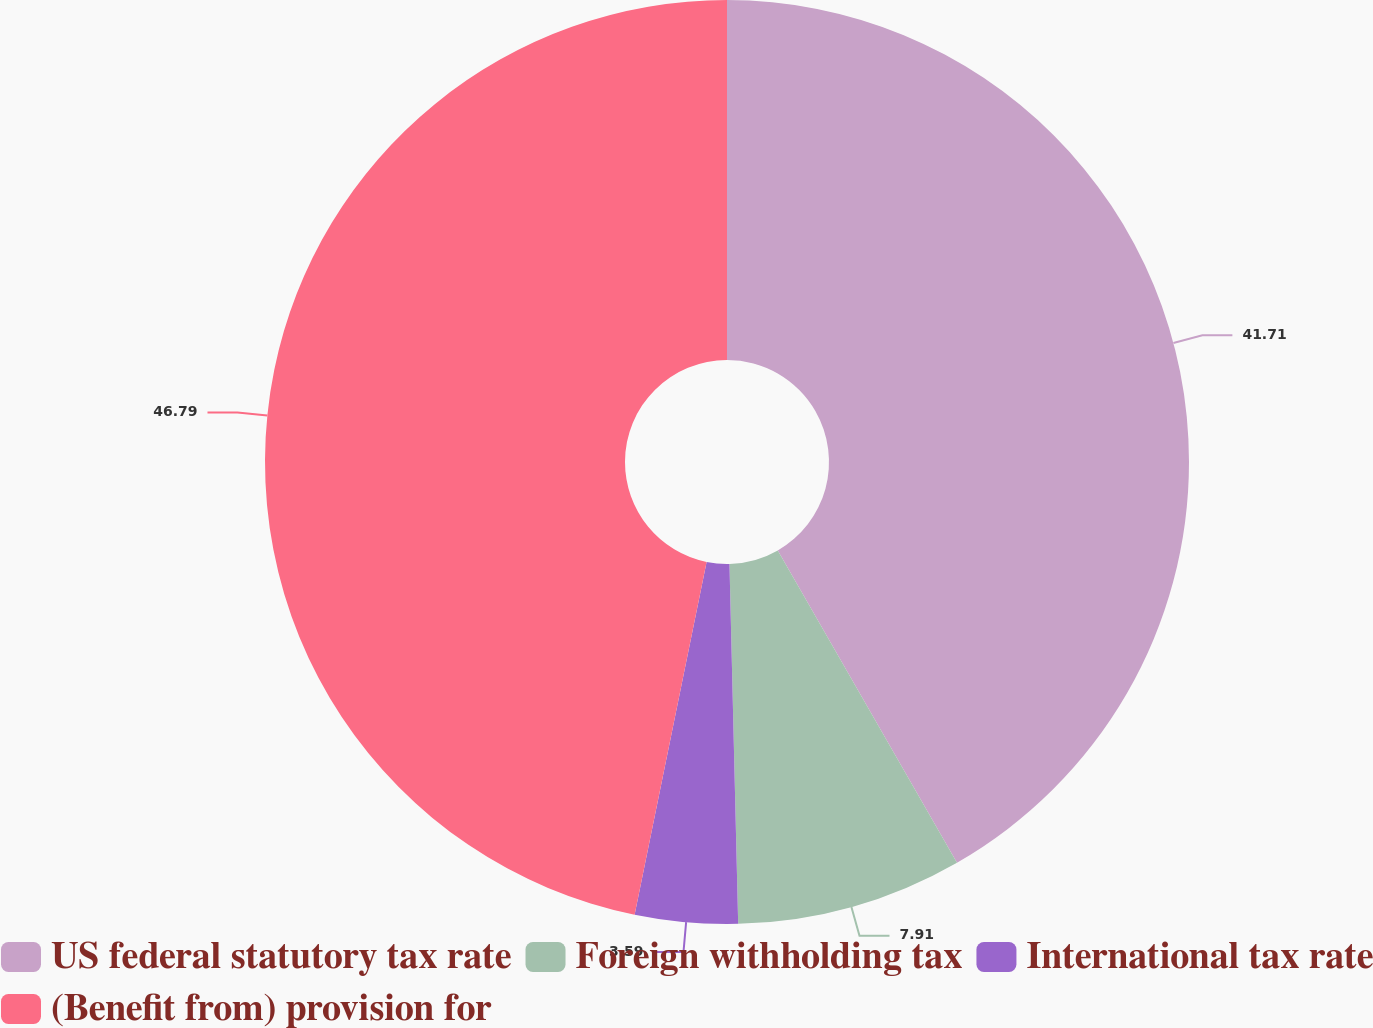Convert chart to OTSL. <chart><loc_0><loc_0><loc_500><loc_500><pie_chart><fcel>US federal statutory tax rate<fcel>Foreign withholding tax<fcel>International tax rate<fcel>(Benefit from) provision for<nl><fcel>41.71%<fcel>7.91%<fcel>3.59%<fcel>46.8%<nl></chart> 